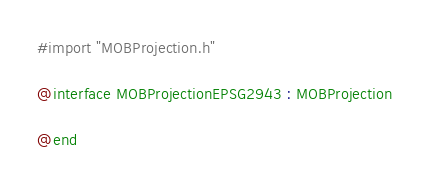Convert code to text. <code><loc_0><loc_0><loc_500><loc_500><_C_>#import "MOBProjection.h"

@interface MOBProjectionEPSG2943 : MOBProjection

@end
</code> 